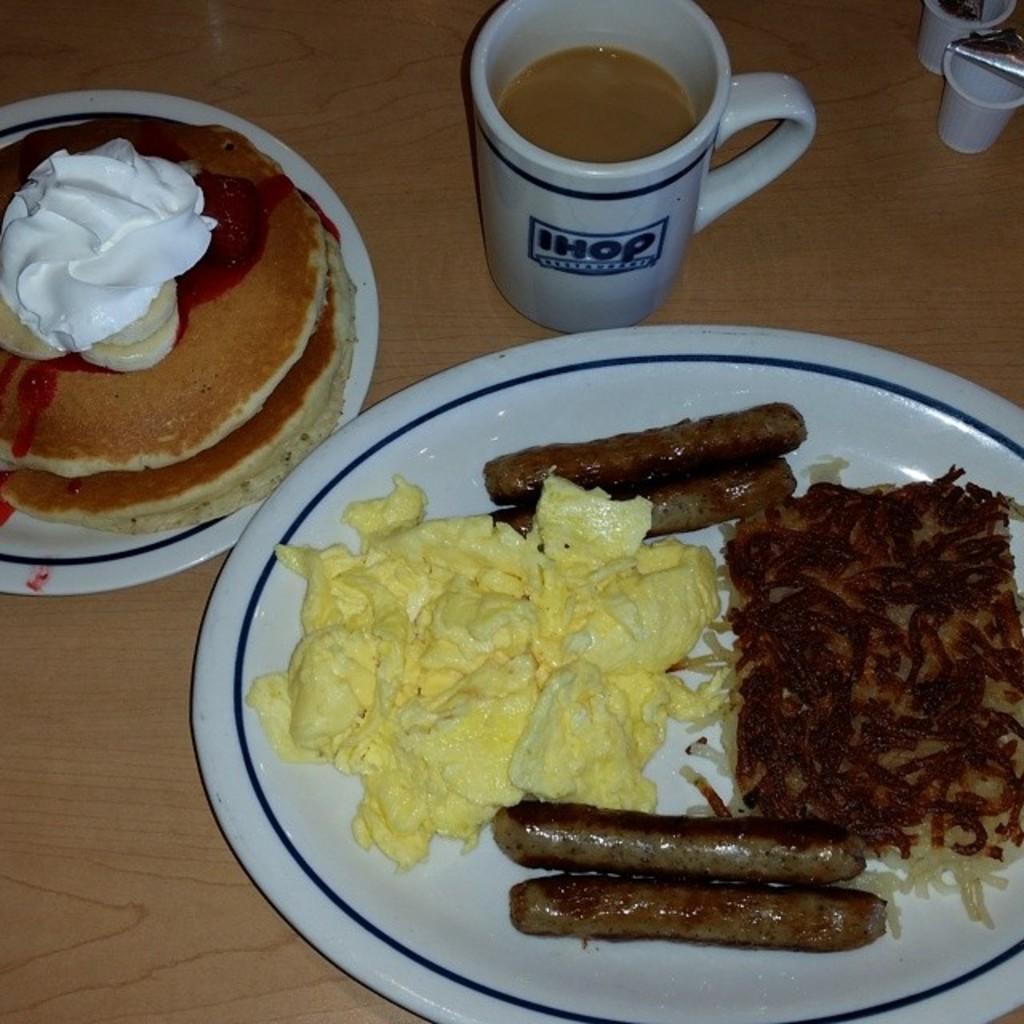Can you describe this image briefly? In this picture there are different food items on the plates. There are plates and there is a cup and there are objects on the table. 